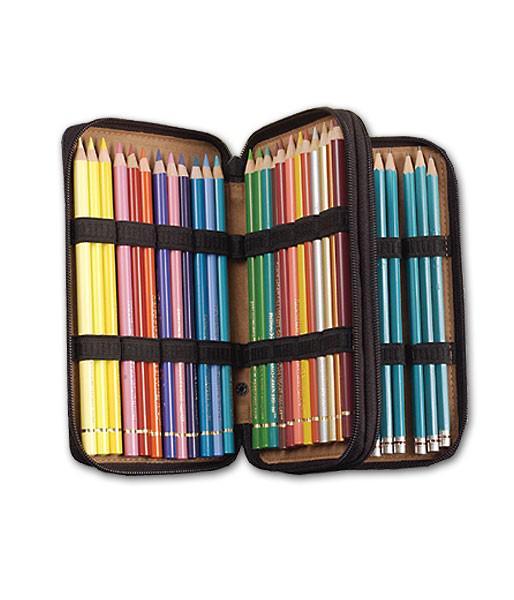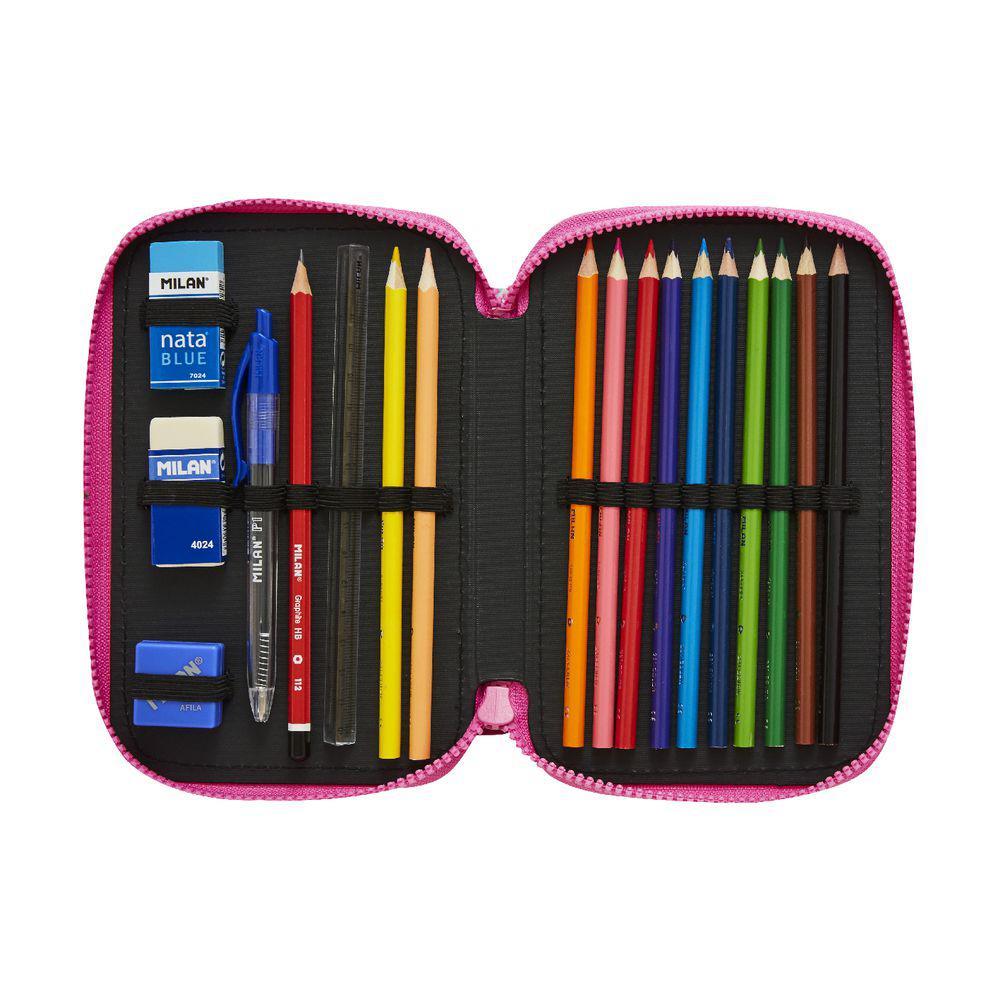The first image is the image on the left, the second image is the image on the right. Analyze the images presented: Is the assertion "The open, filled pencil case on the left has at least one inner compartment that fans out, while the filled case on the right has only a front and back and opens like a clamshell." valid? Answer yes or no. Yes. The first image is the image on the left, the second image is the image on the right. Considering the images on both sides, is "One of the images shows a pencil case with a ruler inside." valid? Answer yes or no. Yes. 